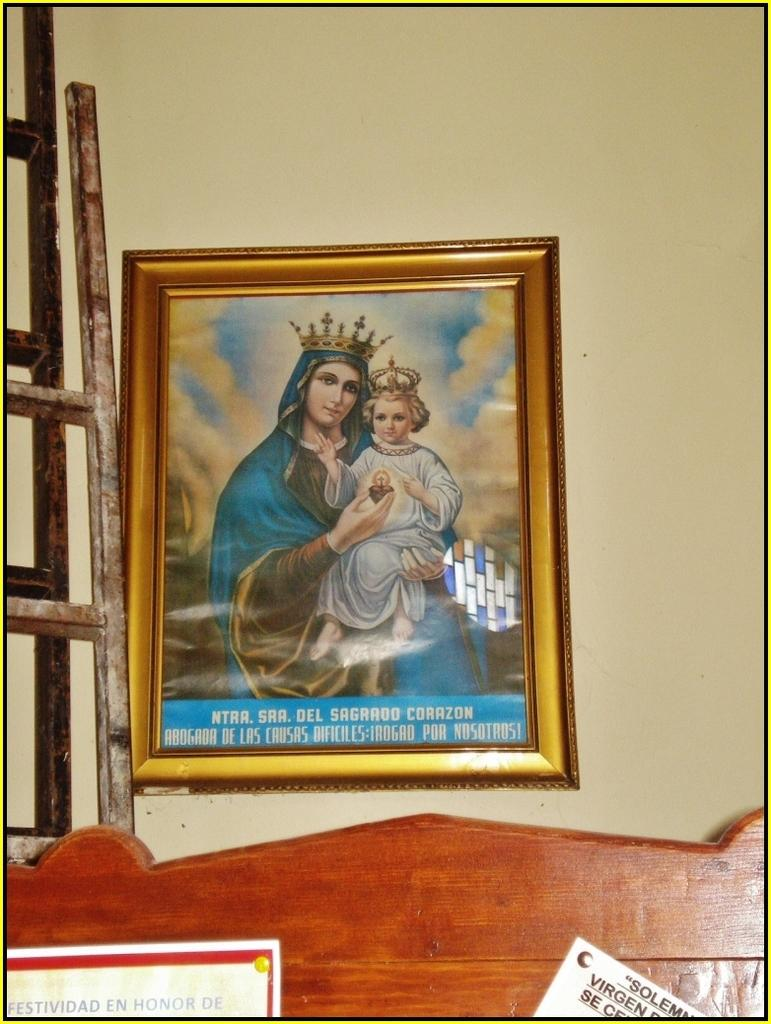<image>
Present a compact description of the photo's key features. Painting of a woman holding a child with the words "NTAA. SAA. Del Sagrado Corazon near the bottom. 